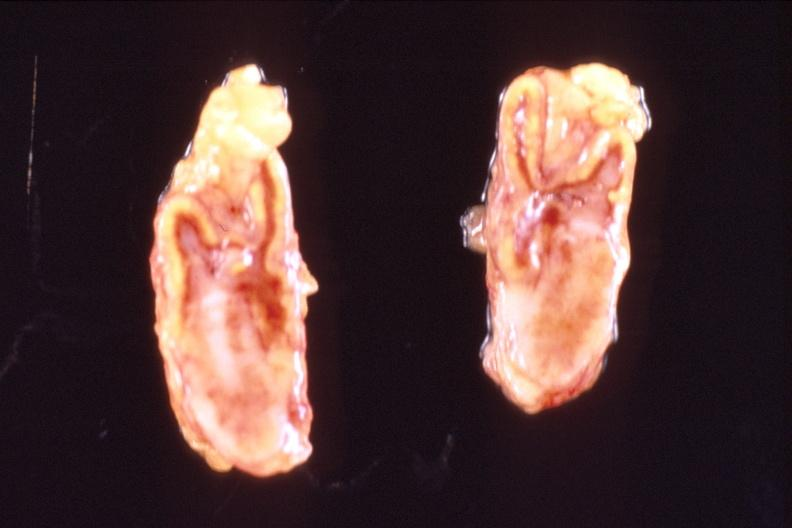s intraductal papillomatosis with apocrine metaplasia present?
Answer the question using a single word or phrase. No 